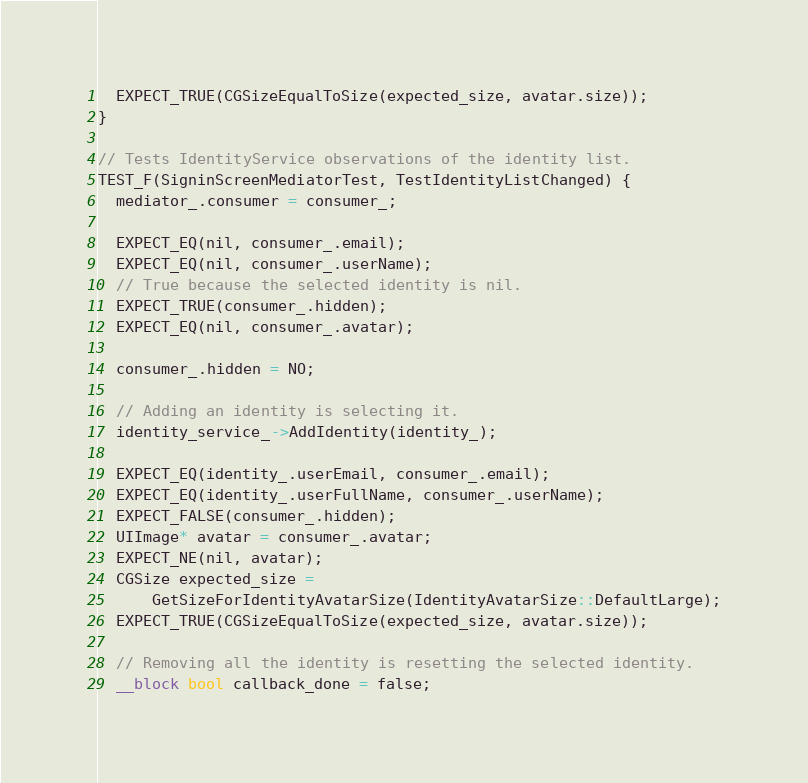Convert code to text. <code><loc_0><loc_0><loc_500><loc_500><_ObjectiveC_>  EXPECT_TRUE(CGSizeEqualToSize(expected_size, avatar.size));
}

// Tests IdentityService observations of the identity list.
TEST_F(SigninScreenMediatorTest, TestIdentityListChanged) {
  mediator_.consumer = consumer_;

  EXPECT_EQ(nil, consumer_.email);
  EXPECT_EQ(nil, consumer_.userName);
  // True because the selected identity is nil.
  EXPECT_TRUE(consumer_.hidden);
  EXPECT_EQ(nil, consumer_.avatar);

  consumer_.hidden = NO;

  // Adding an identity is selecting it.
  identity_service_->AddIdentity(identity_);

  EXPECT_EQ(identity_.userEmail, consumer_.email);
  EXPECT_EQ(identity_.userFullName, consumer_.userName);
  EXPECT_FALSE(consumer_.hidden);
  UIImage* avatar = consumer_.avatar;
  EXPECT_NE(nil, avatar);
  CGSize expected_size =
      GetSizeForIdentityAvatarSize(IdentityAvatarSize::DefaultLarge);
  EXPECT_TRUE(CGSizeEqualToSize(expected_size, avatar.size));

  // Removing all the identity is resetting the selected identity.
  __block bool callback_done = false;</code> 